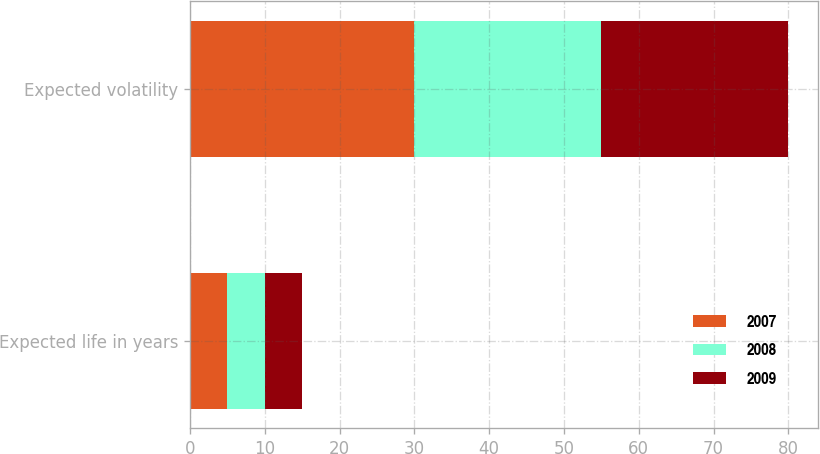<chart> <loc_0><loc_0><loc_500><loc_500><stacked_bar_chart><ecel><fcel>Expected life in years<fcel>Expected volatility<nl><fcel>2007<fcel>5<fcel>30<nl><fcel>2008<fcel>5<fcel>25<nl><fcel>2009<fcel>5<fcel>25<nl></chart> 